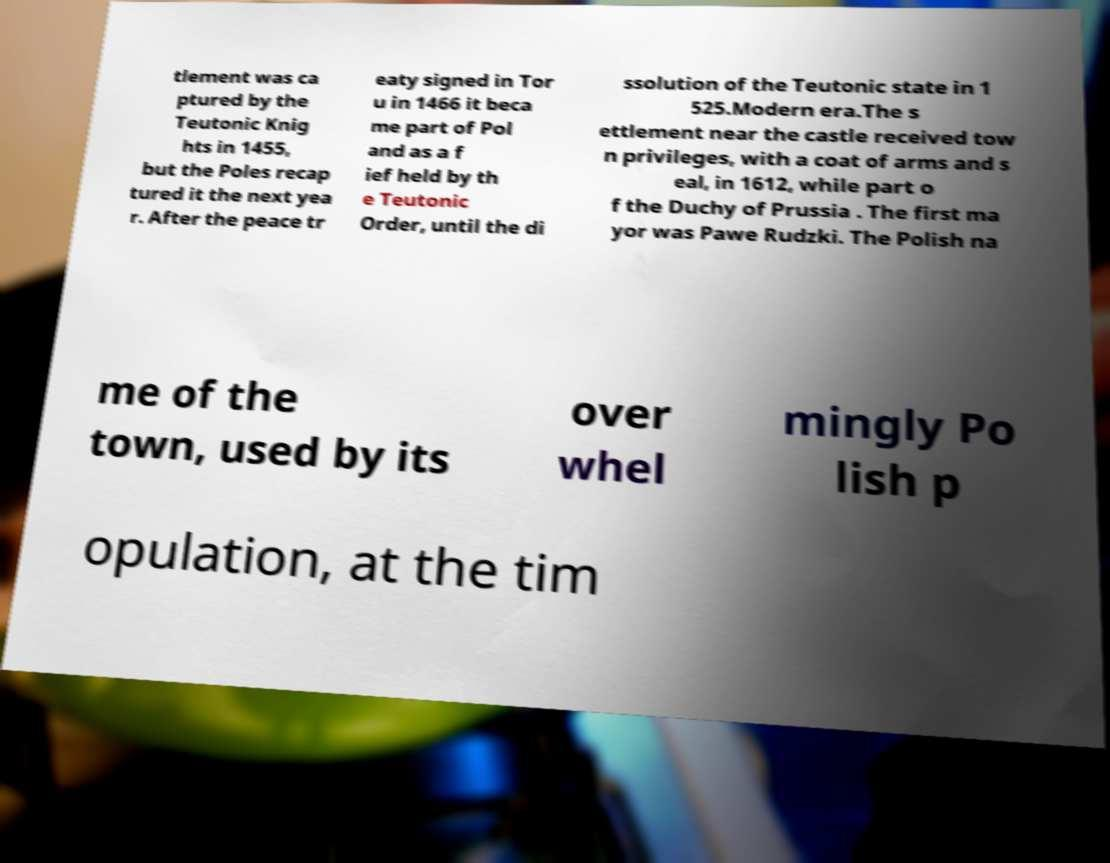Can you read and provide the text displayed in the image?This photo seems to have some interesting text. Can you extract and type it out for me? tlement was ca ptured by the Teutonic Knig hts in 1455, but the Poles recap tured it the next yea r. After the peace tr eaty signed in Tor u in 1466 it beca me part of Pol and as a f ief held by th e Teutonic Order, until the di ssolution of the Teutonic state in 1 525.Modern era.The s ettlement near the castle received tow n privileges, with a coat of arms and s eal, in 1612, while part o f the Duchy of Prussia . The first ma yor was Pawe Rudzki. The Polish na me of the town, used by its over whel mingly Po lish p opulation, at the tim 